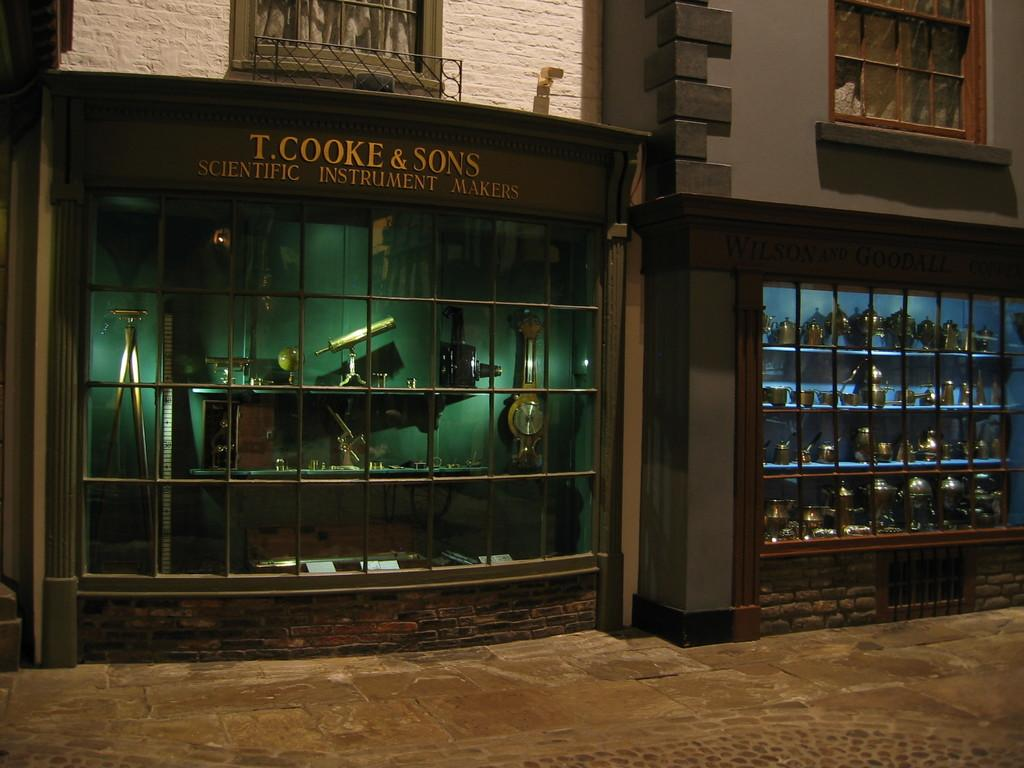What type of store is located in the center of the image? There is an instrument store in the center of the image. What other store can be seen in the image? There is another store at the right side of the image. What is visible at the bottom of the image? There is a road visible at the bottom of the image. How many squirrels are sitting on the roof of the instrument store in the image? There are no squirrels present in the image; it features an instrument store and another store with a road visible at the bottom. What type of star can be seen in the sky above the stores in the image? There is no star visible in the image; it only shows the stores and the road. 